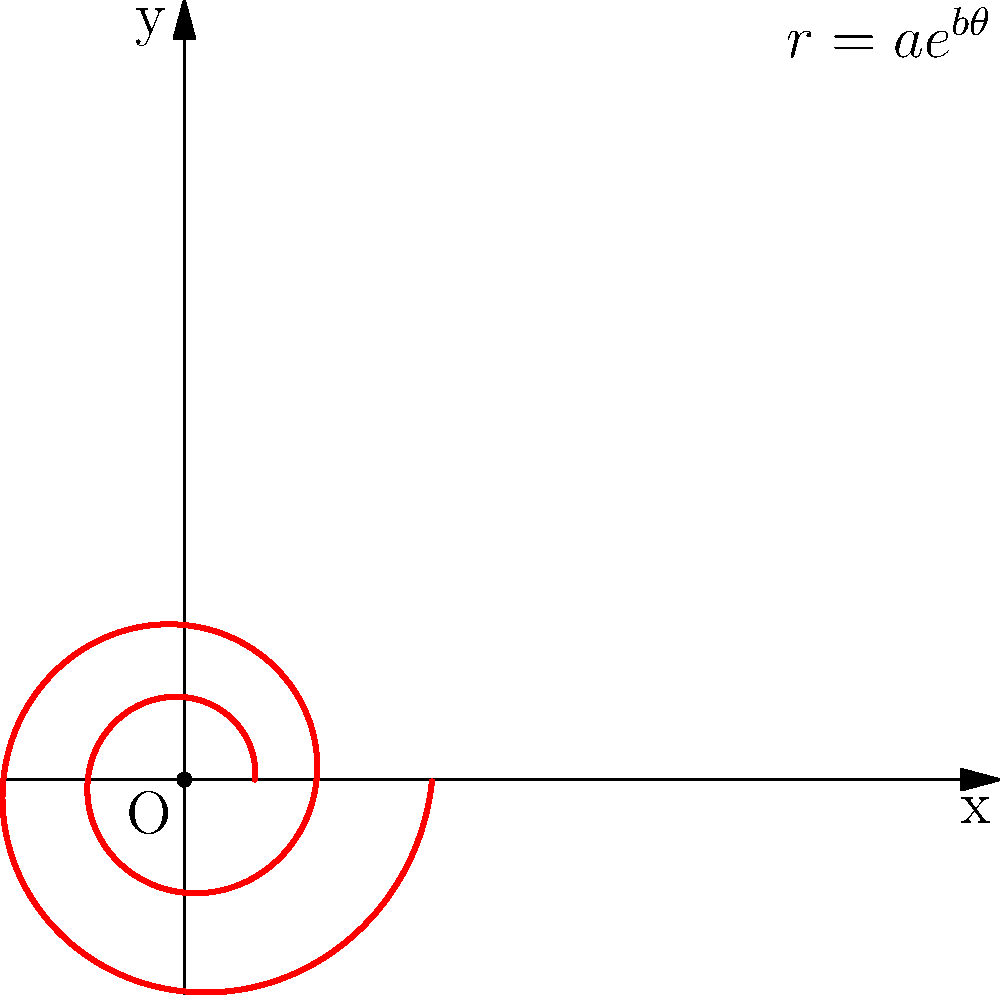In creating a spiral pattern inspired by Victorian furniture motifs using polar coordinates, you decide to use the equation $r = ae^{b\theta}$, where $a = 0.2$ and $b = 0.1$. If you want the spiral to complete two full rotations, what should be the maximum value of $\theta$? To solve this problem, let's follow these steps:

1. Recall that one full rotation in polar coordinates is equal to $2\pi$ radians.

2. Since we want two full rotations, we need to find $\theta$ such that:
   $\theta = 2 \cdot 2\pi = 4\pi$

3. This means that the spiral will make two complete turns when $\theta$ reaches $4\pi$.

4. In the context of Victorian furniture motifs, this spiral could represent intricate scrollwork or curved patterns often found in ornate wood carvings or metalwork details.

5. The equation $r = ae^{b\theta}$ allows for a gradually expanding spiral, which is characteristic of many decorative elements in Victorian design.

6. The parameters $a = 0.2$ and $b = 0.1$ control the initial size and rate of expansion of the spiral, respectively, allowing for fine-tuning to match specific furniture motifs.

Therefore, to complete two full rotations, the maximum value of $\theta$ should be $4\pi$.
Answer: $4\pi$ 